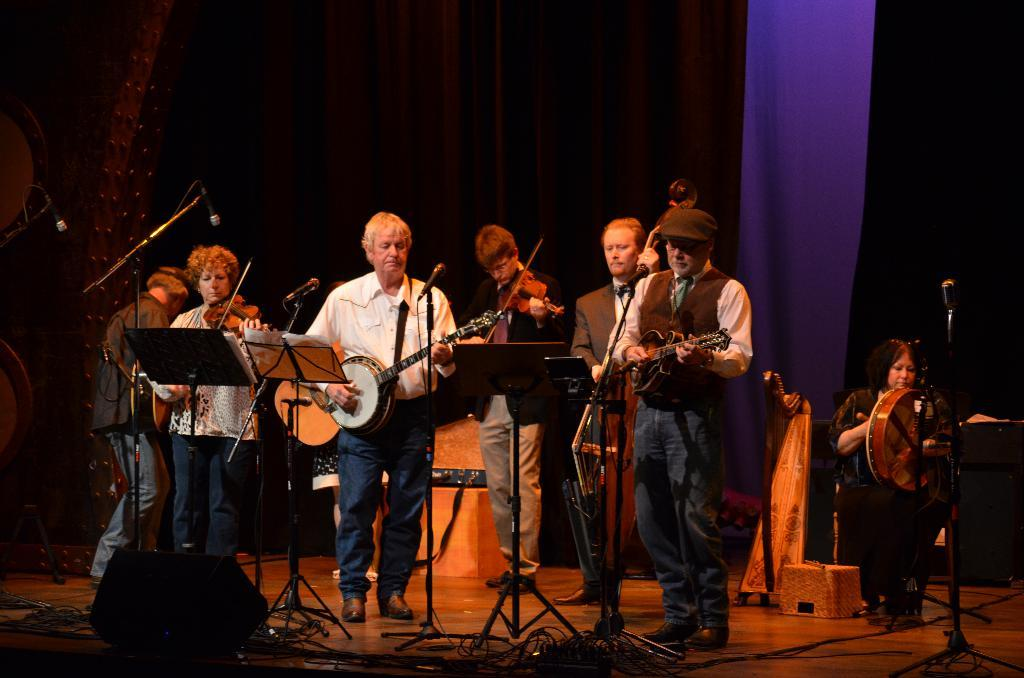What are the people in the image doing? The people in the image are standing and holding musical instruments. Can you describe the woman in the image? The woman in the image is sitting and playing a drum. What type of truck can be seen in the background of the image? There is no truck present in the image. Can you tell me how many copies of the drum the woman is playing? The woman is playing one drum, not multiple copies. 